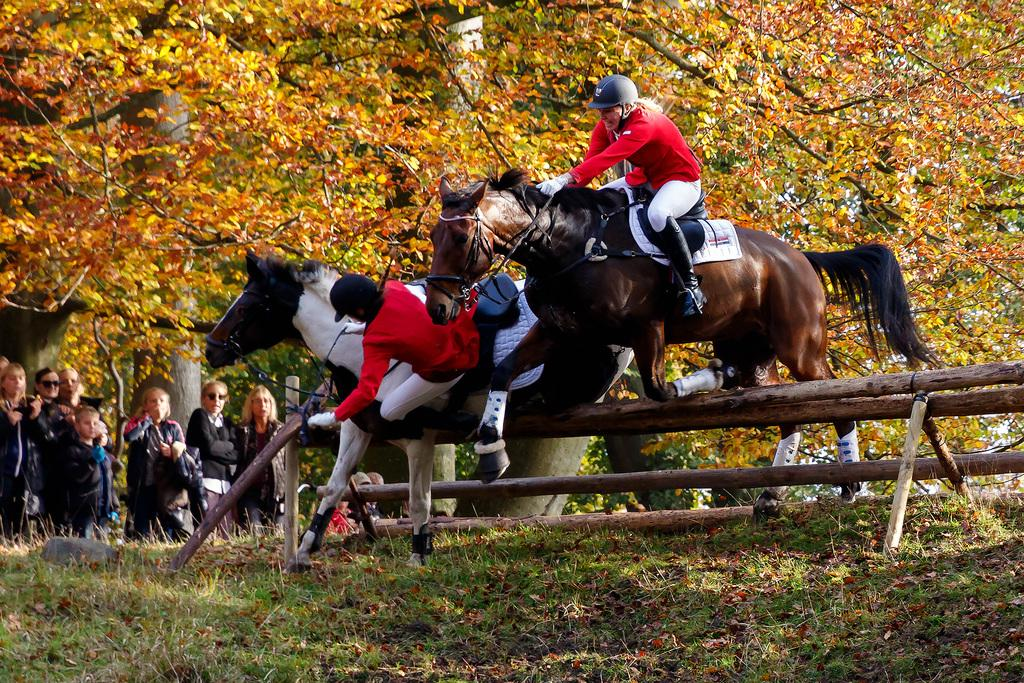What animals are present in the image? There are two horses in the image. What are the horses doing in the image? The horses are jumping over hurdles in the image. Who is riding the horses? There are two persons riding the horses in the image. What can be seen in the background of the image? There is a group of people and trees visible in the background of the image. How many dimes can be seen on the ground near the horses? There are no dimes visible in the image; it features horses jumping over hurdles with riders. What type of finger is being used by the riders to control the horses? The image does not show any fingers being used to control the horses; it only shows the horses and riders jumping over hurdles. 